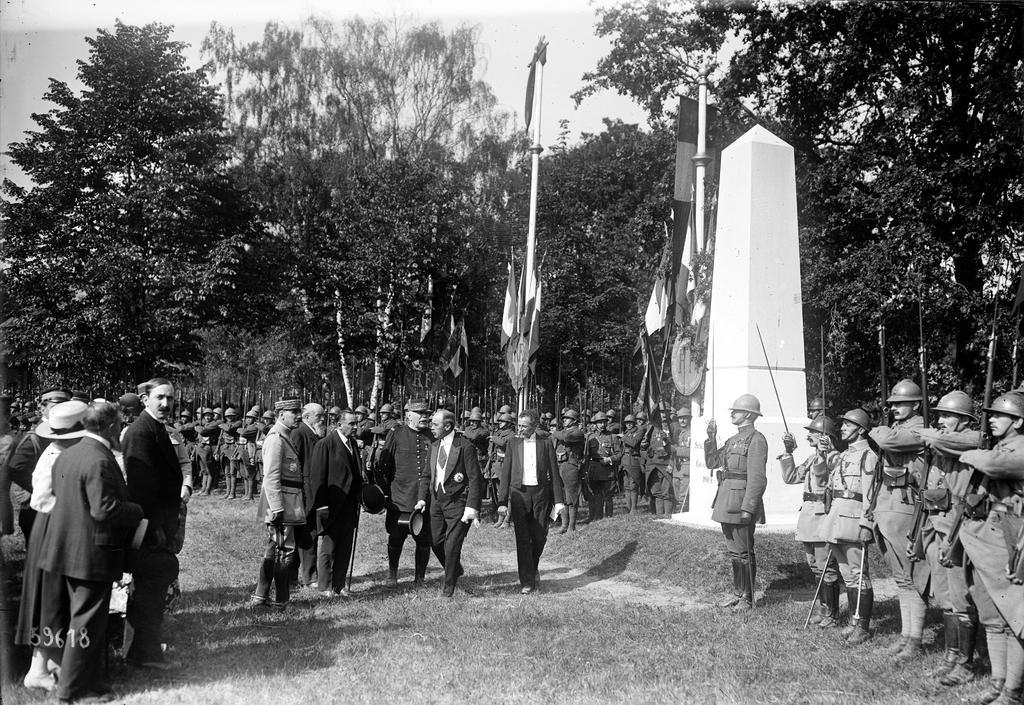Describe this image in one or two sentences. It is the black and white image, few people are standing, these are the trees. On the right side there is a concrete tower. 